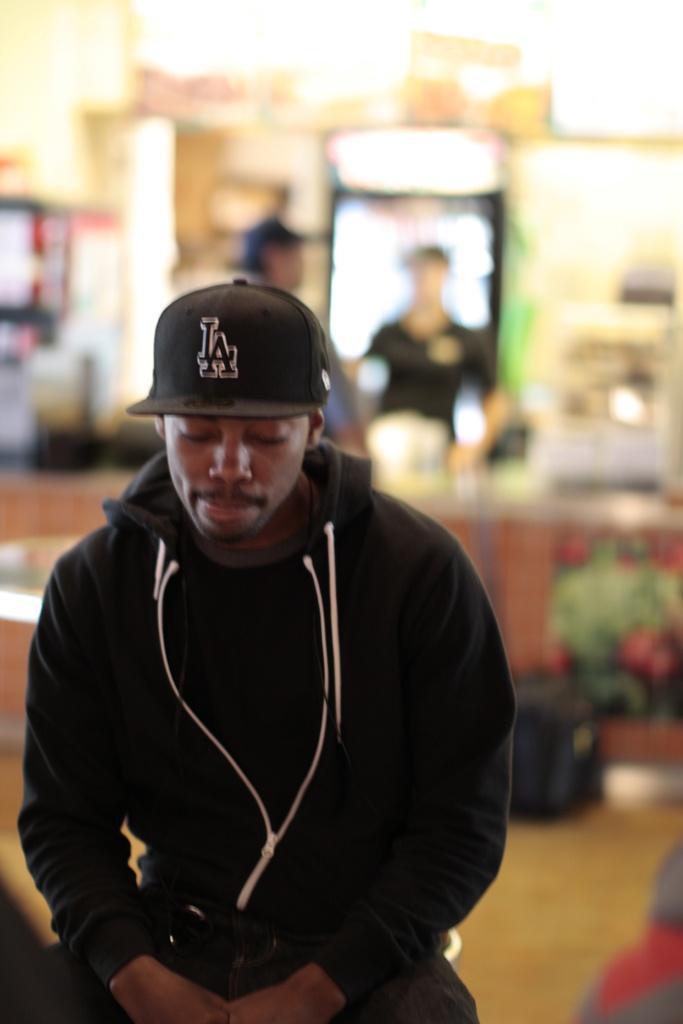Describe this image in one or two sentences. In this image we can see a man who is wearing black color t-shirt, jacket with cap. Background of the image two men are standing. 